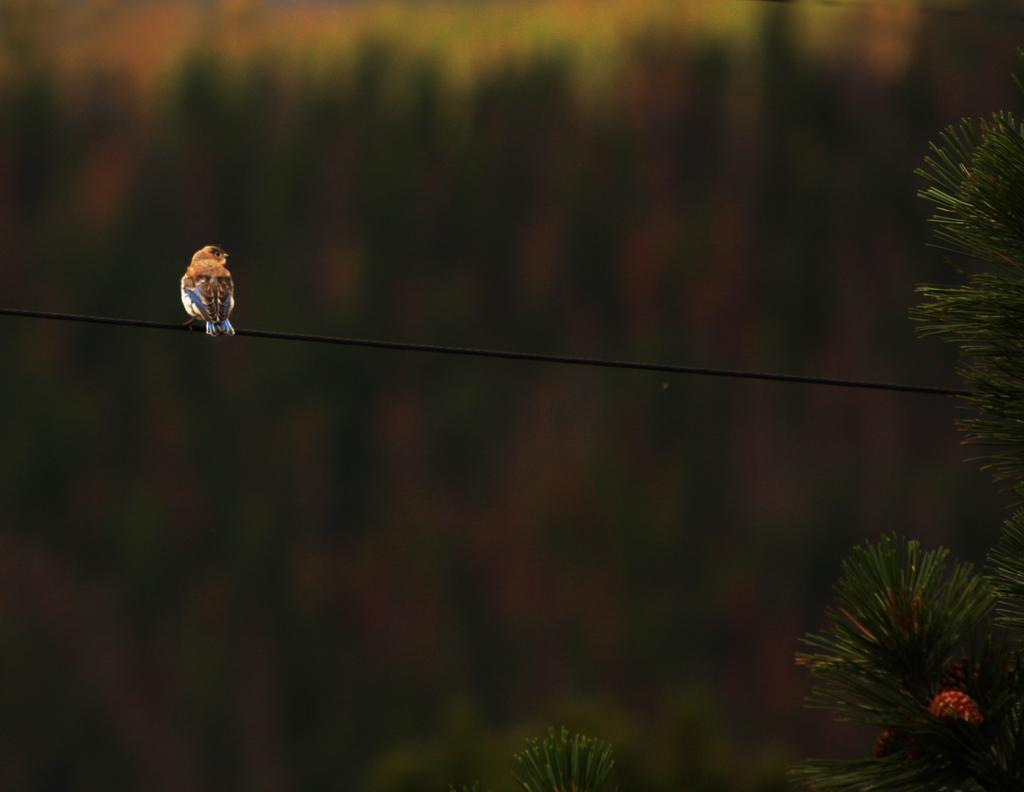Describe this image in one or two sentences. In this image we can see a bird on cable. In the background, we can see some trees. 